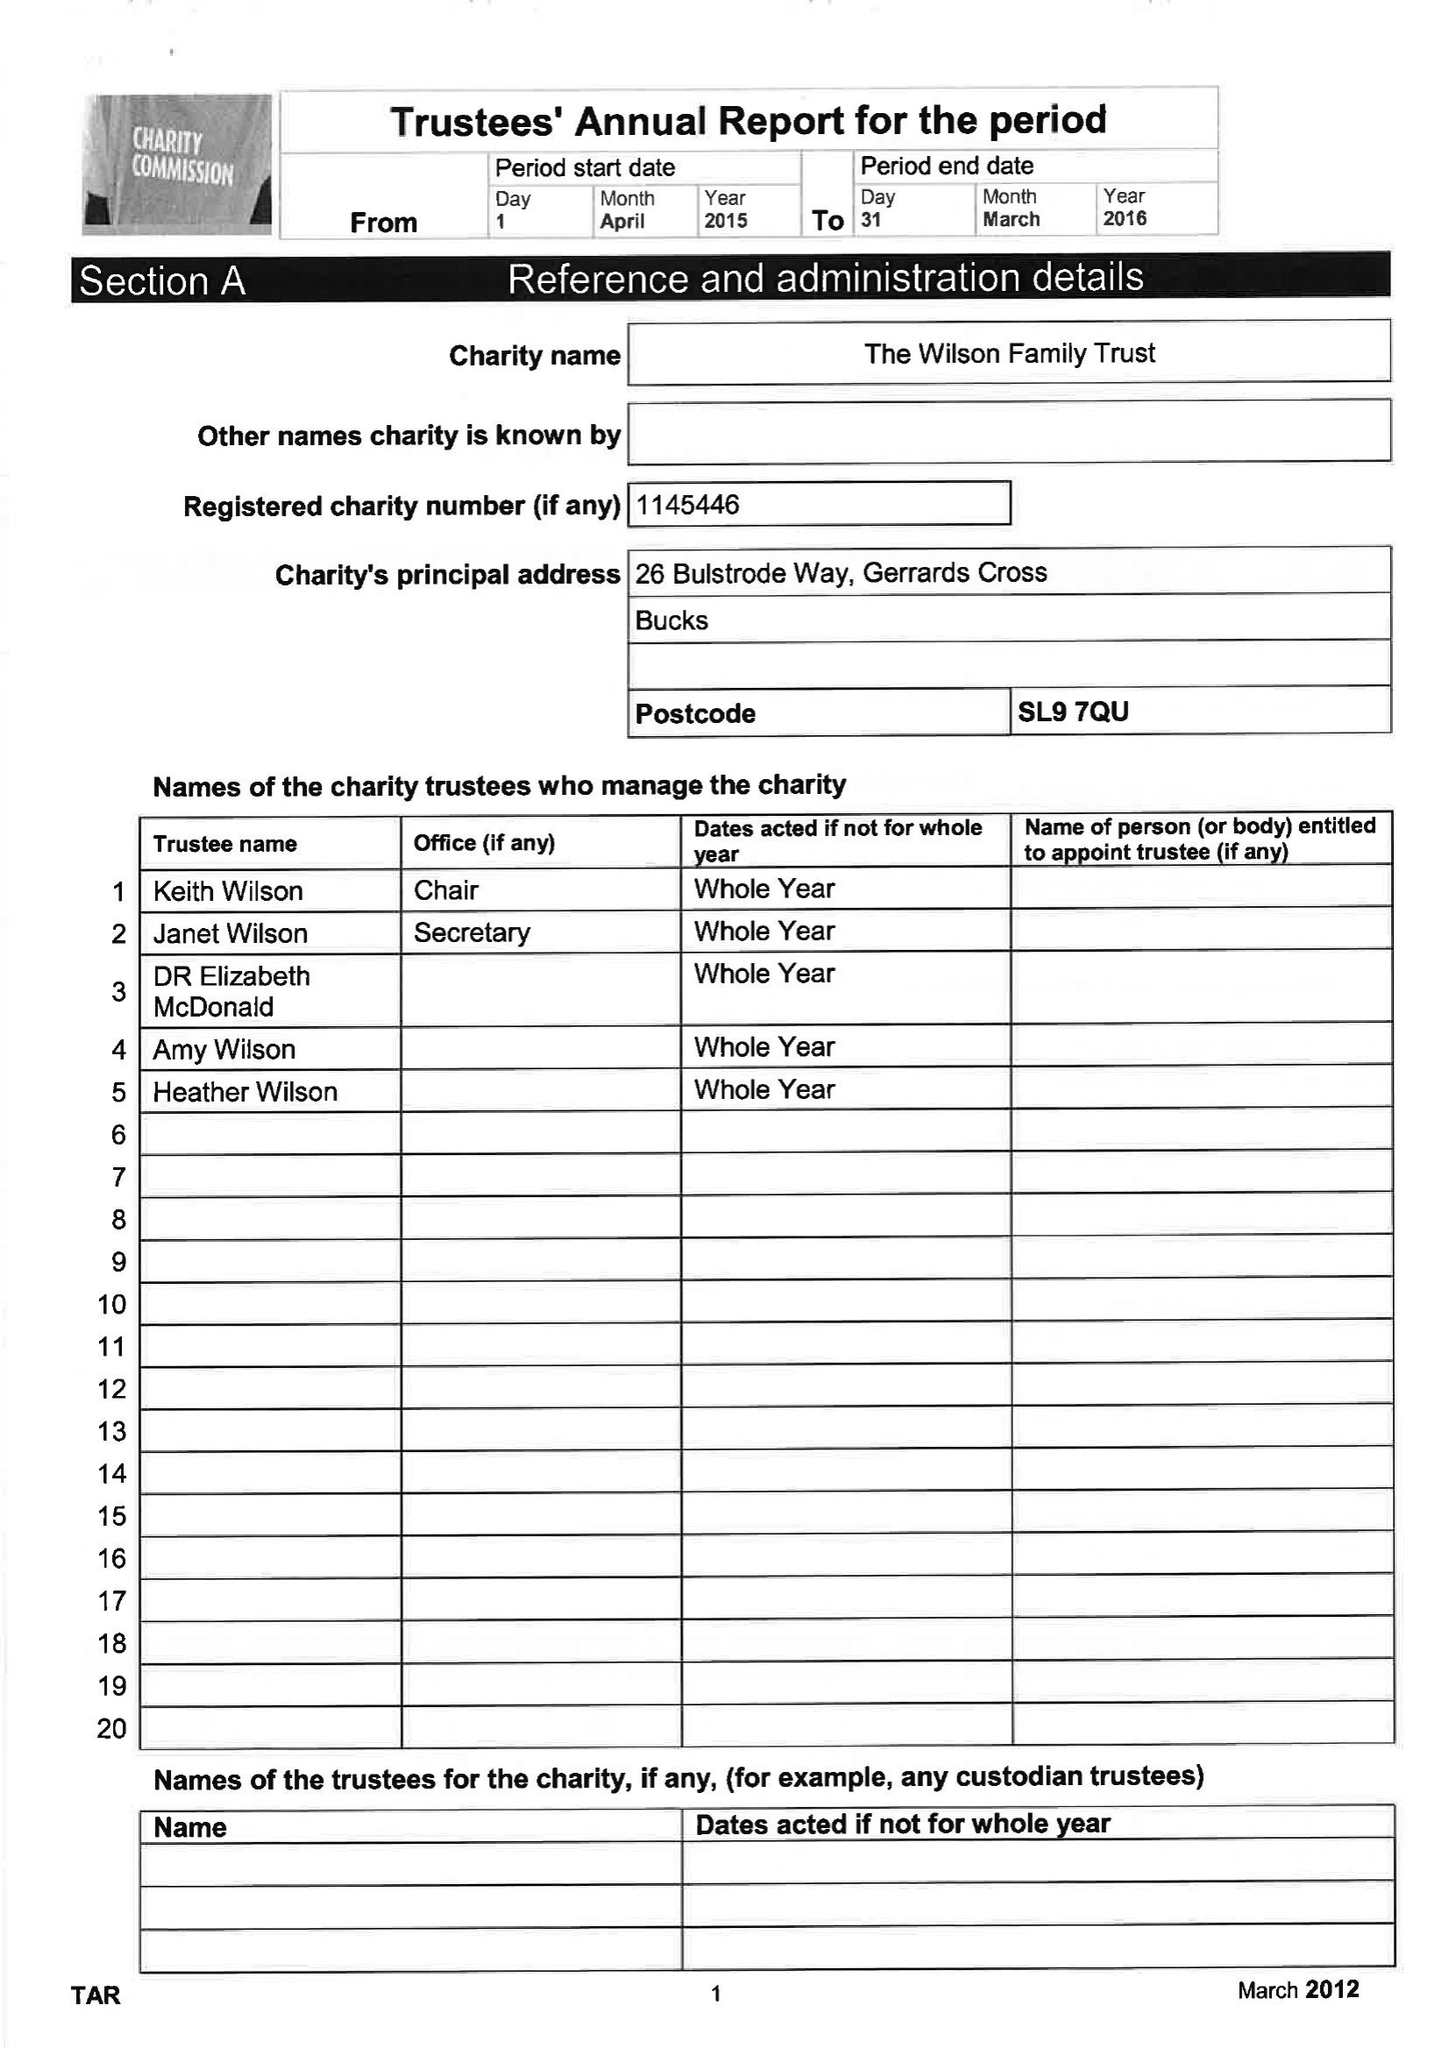What is the value for the report_date?
Answer the question using a single word or phrase. 2016-04-05 